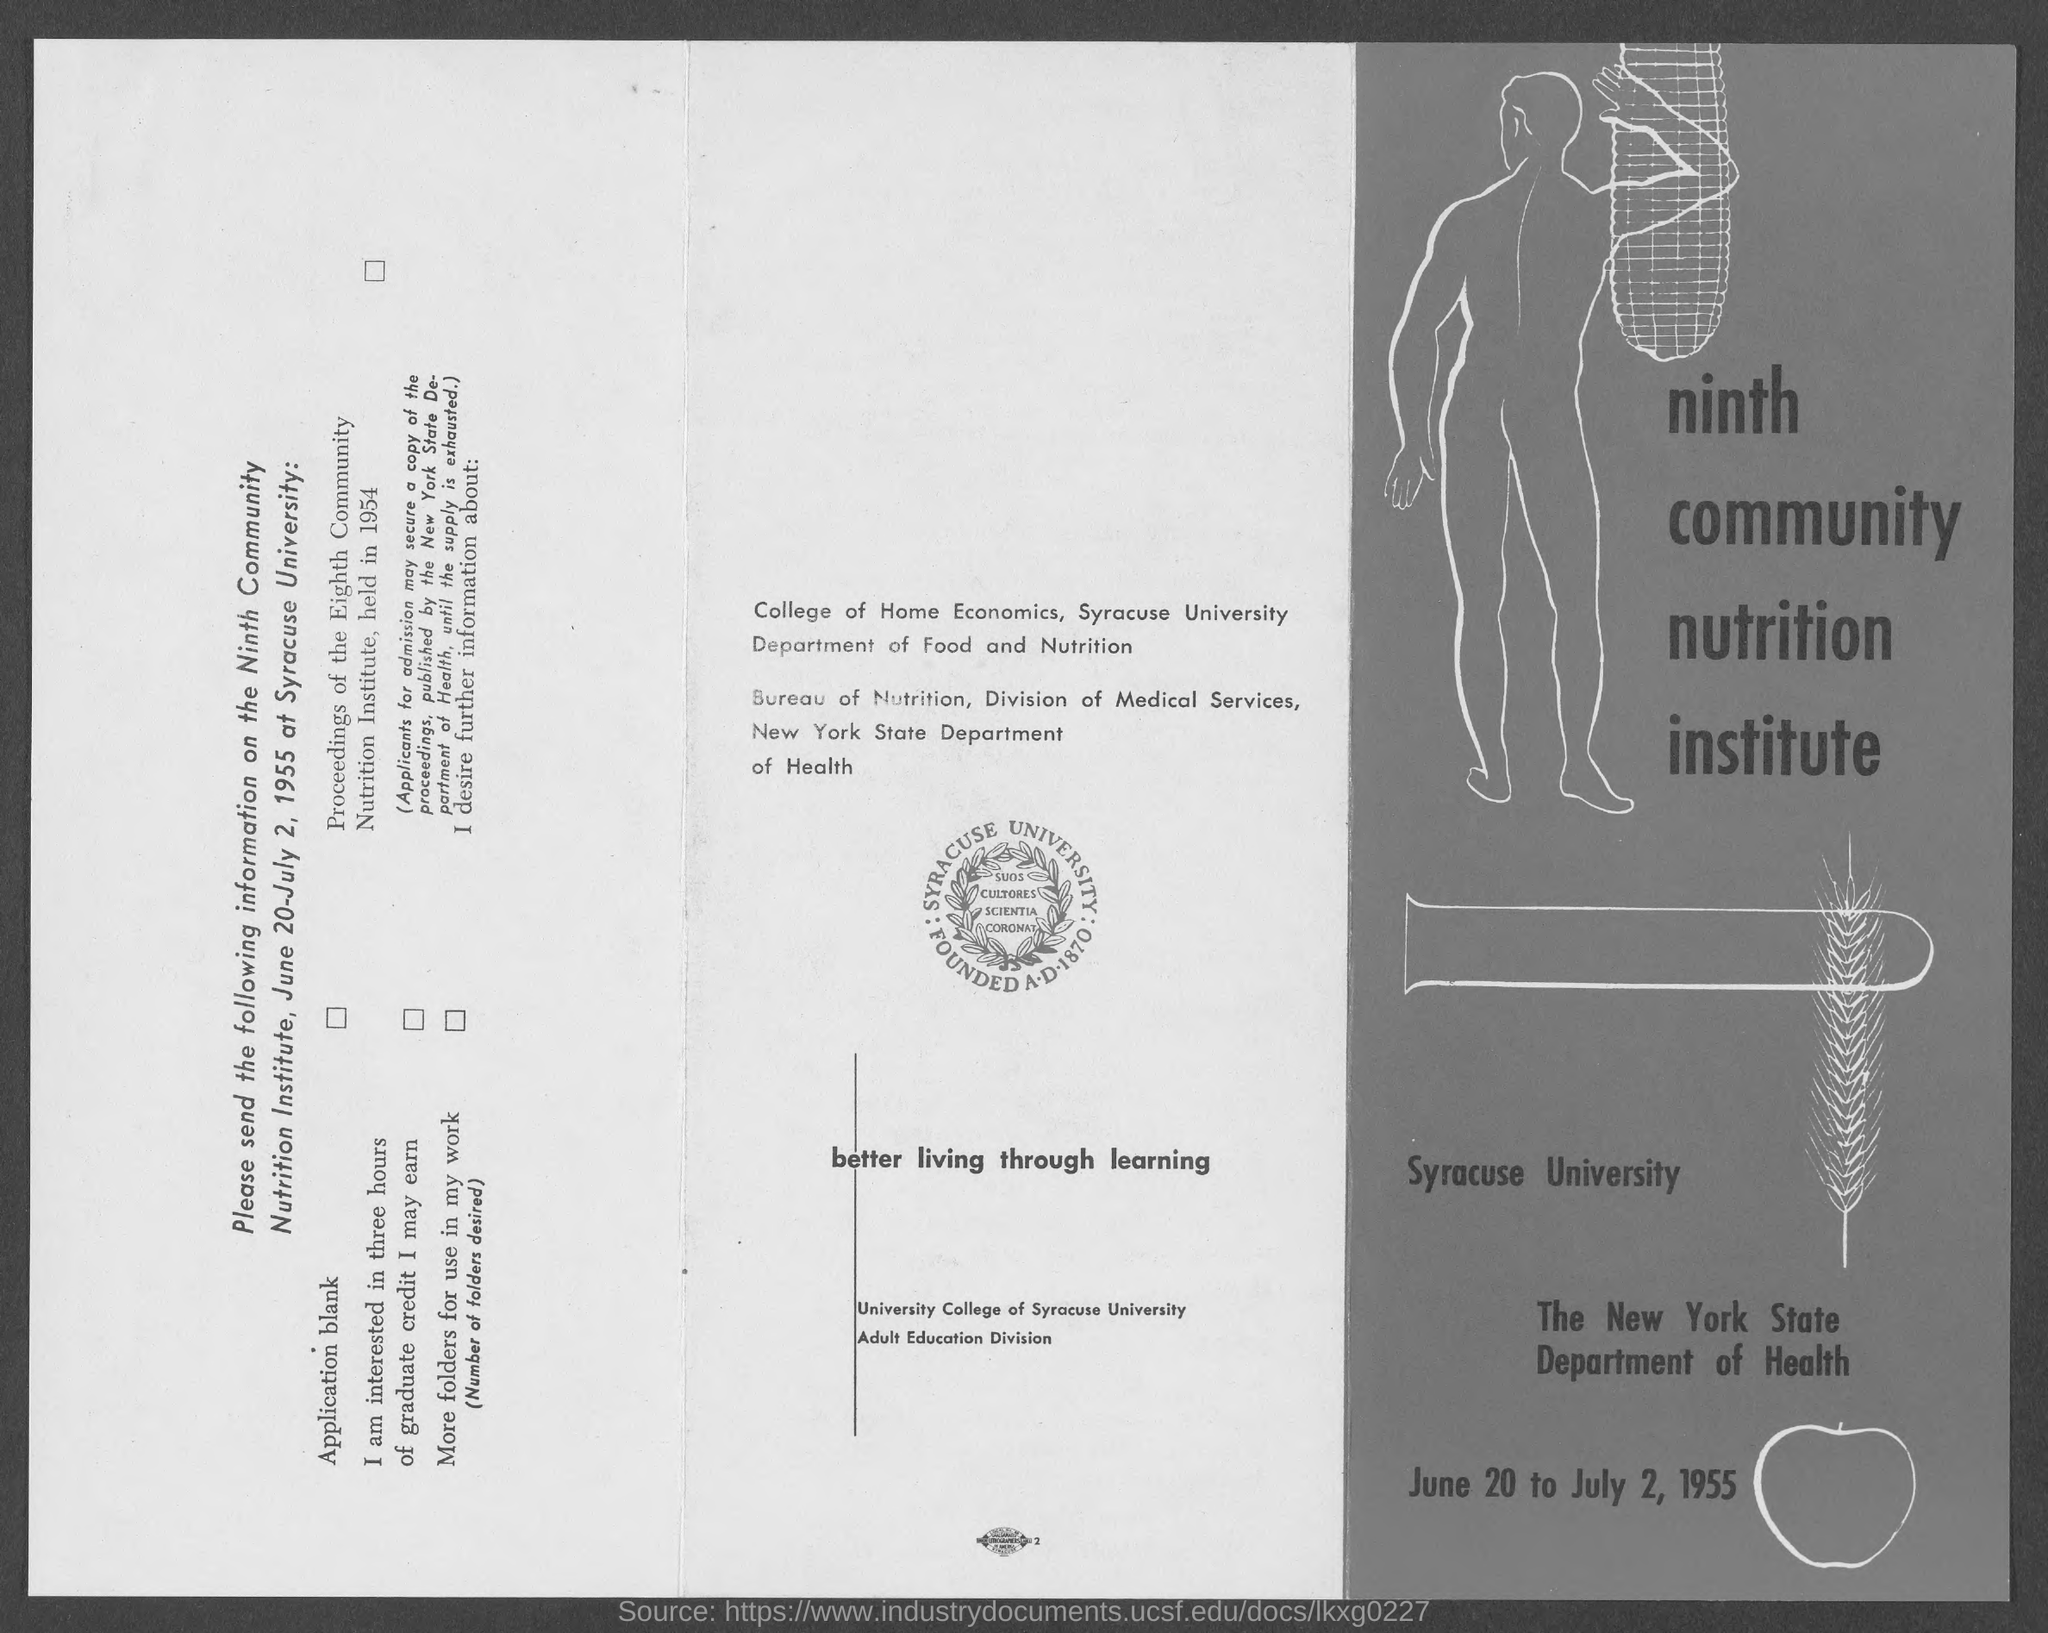Outline some significant characteristics in this image. Syracuse University is located in the state of New York. Syracuse University is mentioned in the picture. 